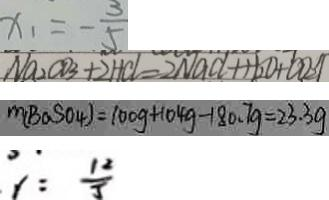<formula> <loc_0><loc_0><loc_500><loc_500>x _ { 1 } = - \frac { 3 } { 5 } 
 N a _ { 2 } C O _ { 3 } + 2 H C l = 2 N a C l + H _ { 2 } O + C O _ { 2 } \uparrow 
 m ( B a S O _ { 4 } ) = 1 0 0 g + 1 0 4 g - 1 8 0 . 7 g = 2 3 . 3 g 
 y = \frac { 1 2 } { 5 }</formula> 